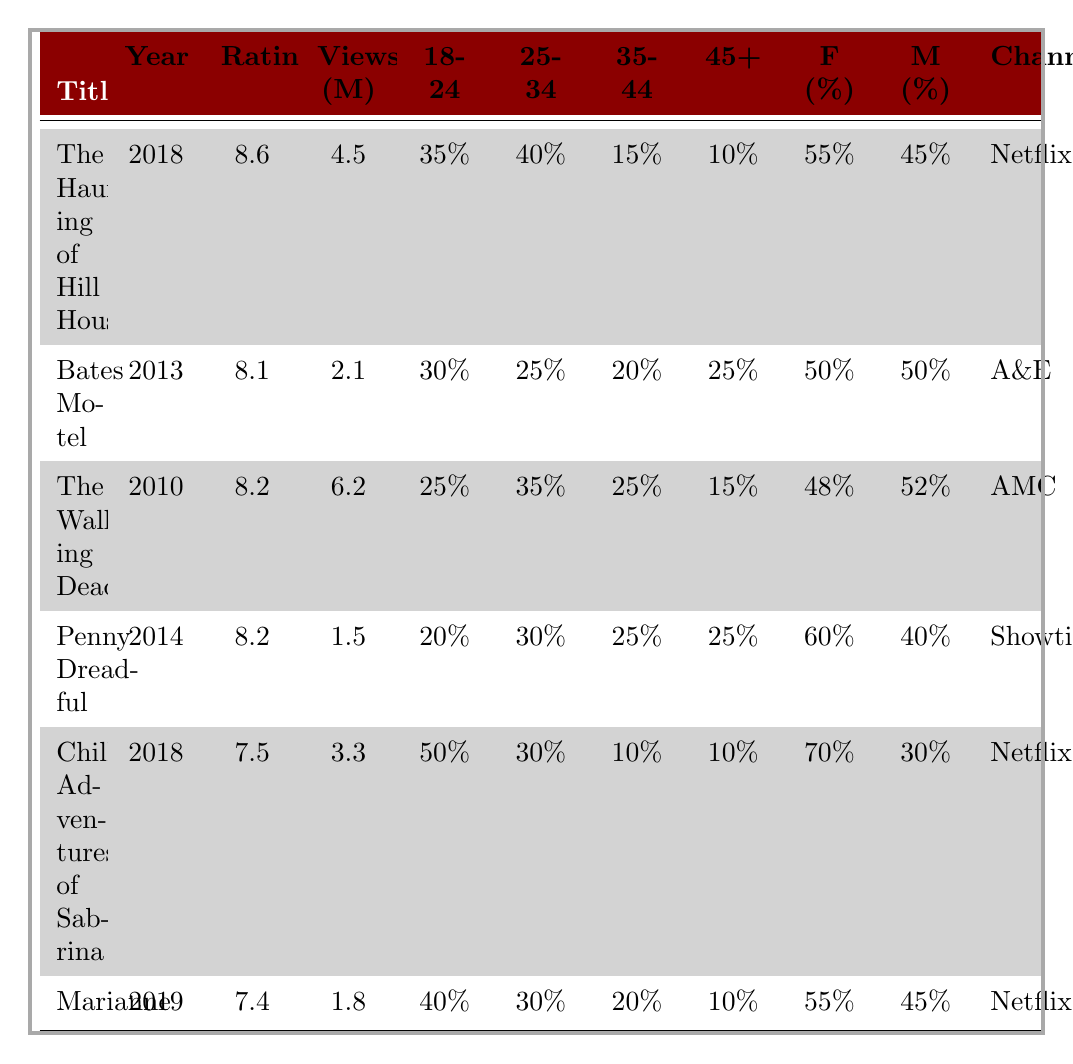What is the average rating of "The Haunting of Hill House"? The average rating of "The Haunting of Hill House" is listed in the table, which shows 8.6.
Answer: 8.6 Which channel aired "Penny Dreadful"? Referring to the table, "Penny Dreadful" is listed under the channel "Showtime."
Answer: Showtime How many viewers (in millions) did "The Walking Dead" have? The viewership of "The Walking Dead" is listed in the table as 6.2 million.
Answer: 6.2 million What percentage of viewers for "Chilling Adventures of Sabrina" are female? The table shows that 70% of the viewers for "Chilling Adventures of Sabrina" are female.
Answer: 70% Which horror drama has the most viewership? By comparing the viewership numbers in the table, "The Walking Dead" has the highest viewership at 6.2 million.
Answer: The Walking Dead What is the total percentage of viewers aged 35 and above for "Bates Motel"? Adding the percentages for age groups 35-44 (20%) and 45+ (25%), the total is 45%.
Answer: 45% Is "Marianne" rated higher than "Chilling Adventures of Sabrina"? Comparing the average ratings in the table, "Marianne" has a rating of 7.4, which is lower than "Chilling Adventures of Sabrina" at 7.5. Thus, the answer is no.
Answer: No Which age group has the highest percentage of viewers for "The Haunting of Hill House"? The table shows that the 25-34 age group has the highest percentage of viewers at 40% for "The Haunting of Hill House."
Answer: 25-34 age group What is the average rating of the horror dramas listed in the table? The average rating can be computed by adding the ratings: (8.6 + 8.1 + 8.2 + 8.2 + 7.5 + 7.4) = 47.0 and then dividing by the number of dramas (6), resulting in approximately 7.83.
Answer: 7.83 For which drama is the gender distribution equal between male and female viewers? The table shows that "Bates Motel" has an equal gender distribution with 50% male and 50% female viewers.
Answer: Bates Motel 